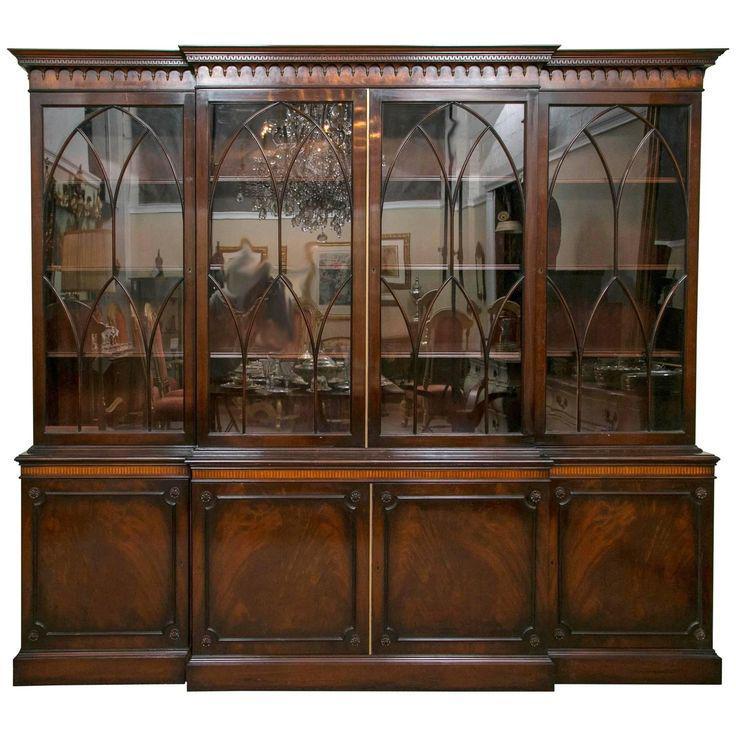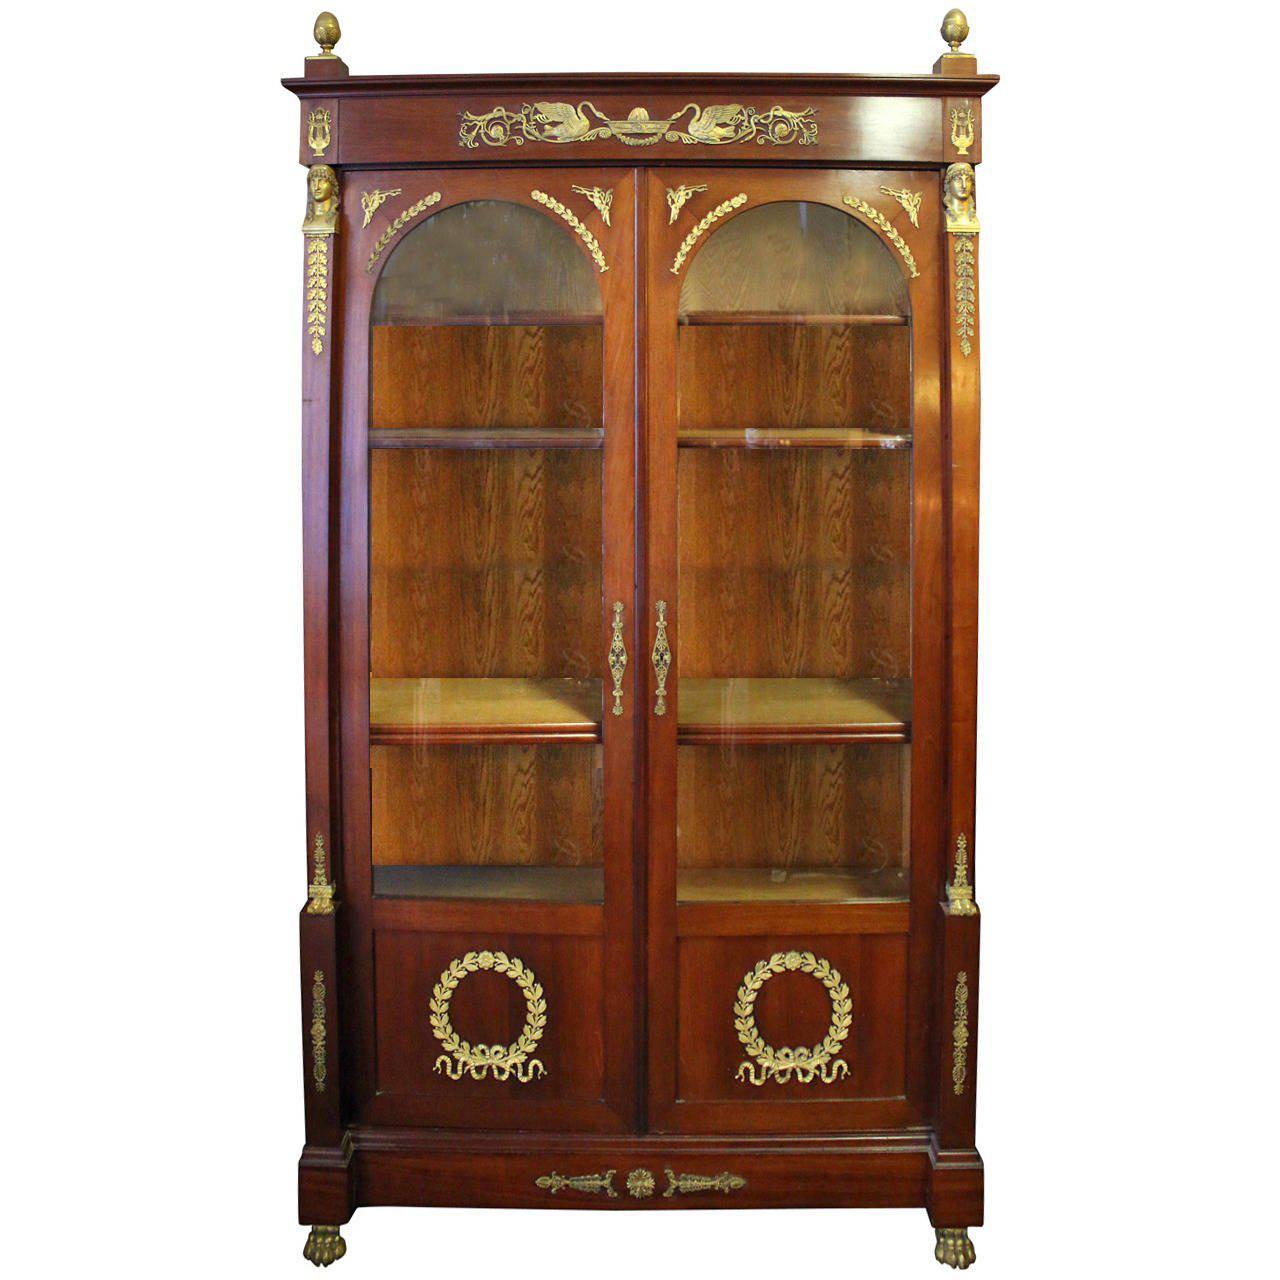The first image is the image on the left, the second image is the image on the right. Considering the images on both sides, is "In one of the images there is a bookshelf with books on it." valid? Answer yes or no. No. 